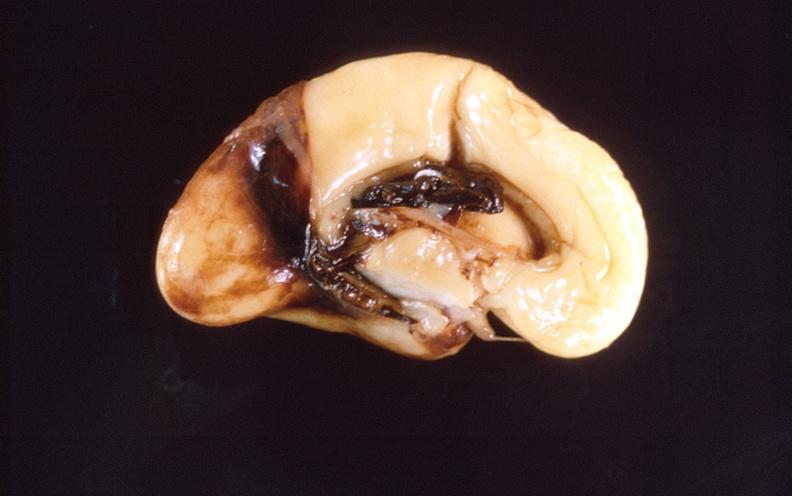does this image show intraventricular hemorrhage, neonate brain?
Answer the question using a single word or phrase. Yes 